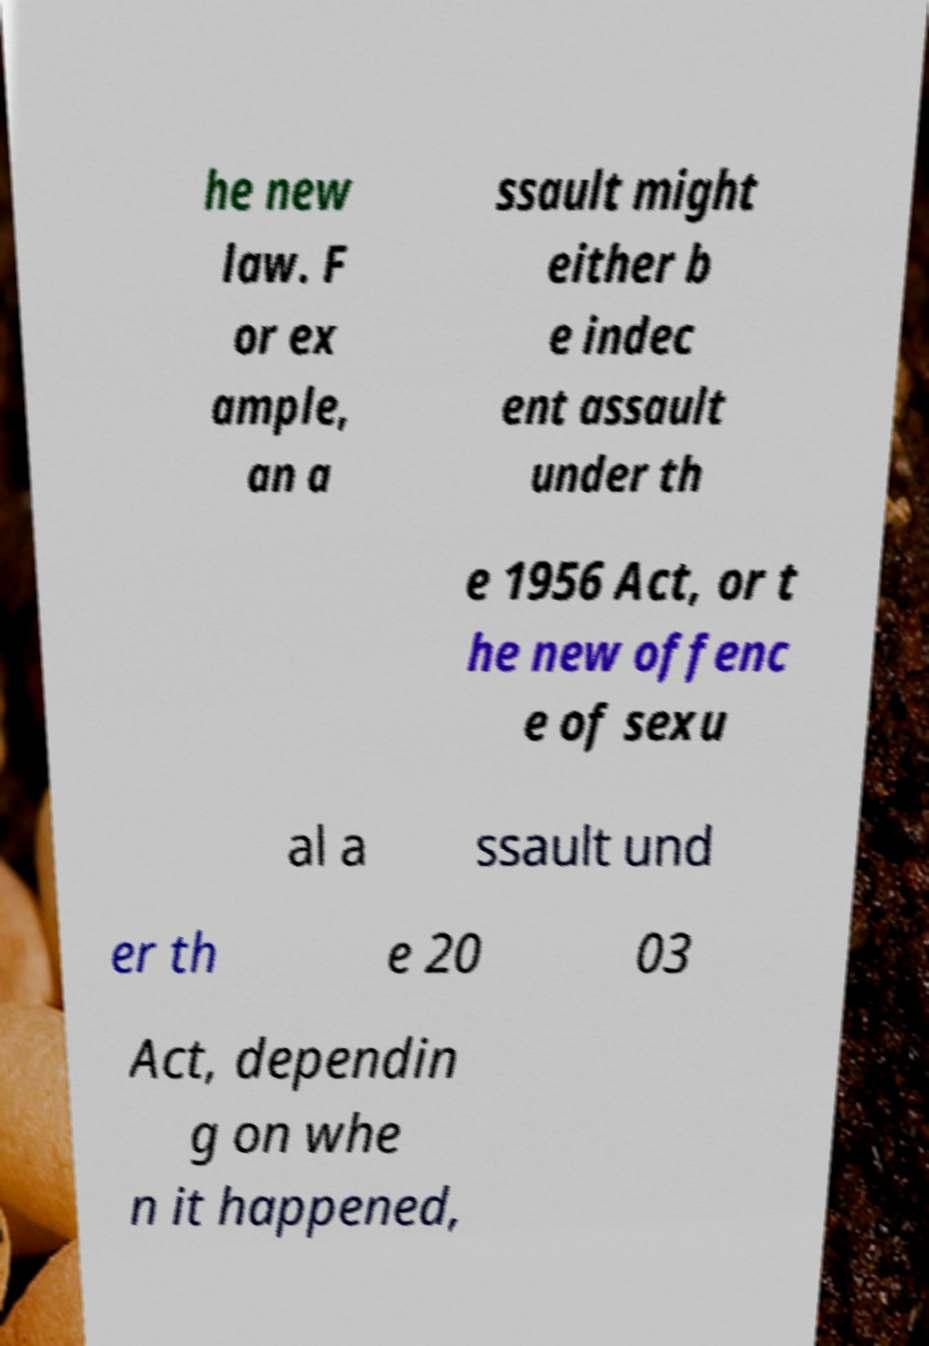What messages or text are displayed in this image? I need them in a readable, typed format. he new law. F or ex ample, an a ssault might either b e indec ent assault under th e 1956 Act, or t he new offenc e of sexu al a ssault und er th e 20 03 Act, dependin g on whe n it happened, 